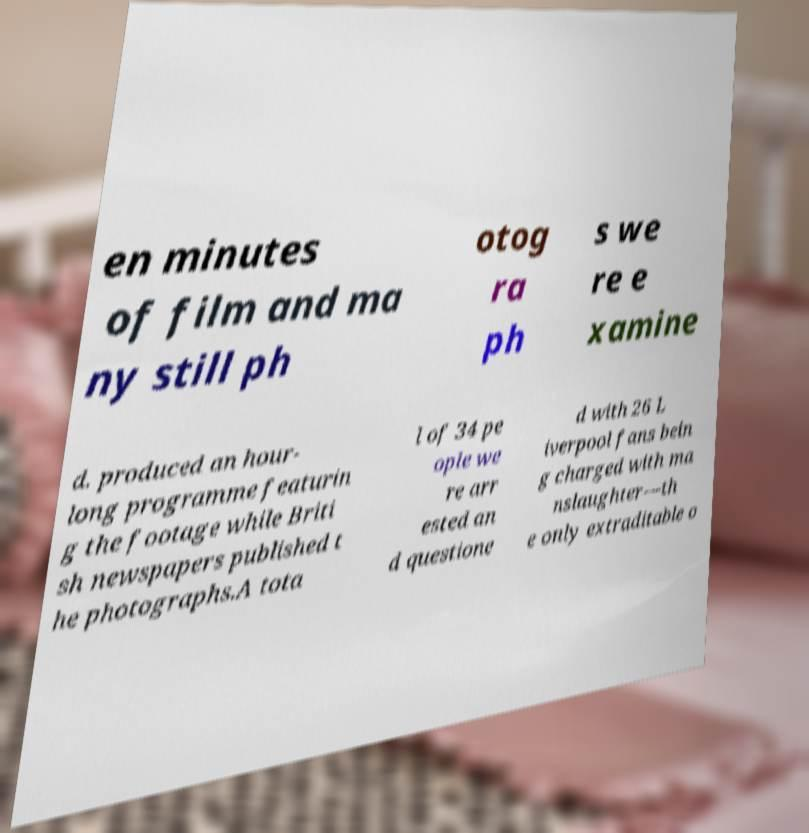There's text embedded in this image that I need extracted. Can you transcribe it verbatim? en minutes of film and ma ny still ph otog ra ph s we re e xamine d. produced an hour- long programme featurin g the footage while Briti sh newspapers published t he photographs.A tota l of 34 pe ople we re arr ested an d questione d with 26 L iverpool fans bein g charged with ma nslaughter—th e only extraditable o 